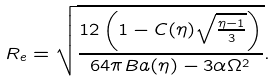<formula> <loc_0><loc_0><loc_500><loc_500>R _ { e } = \sqrt { \frac { 1 2 \left ( 1 - C ( \eta ) \sqrt { \frac { \eta - 1 } { 3 } } \right ) } { 6 4 \pi B a ( \eta ) - 3 \alpha \Omega ^ { 2 } } } .</formula> 